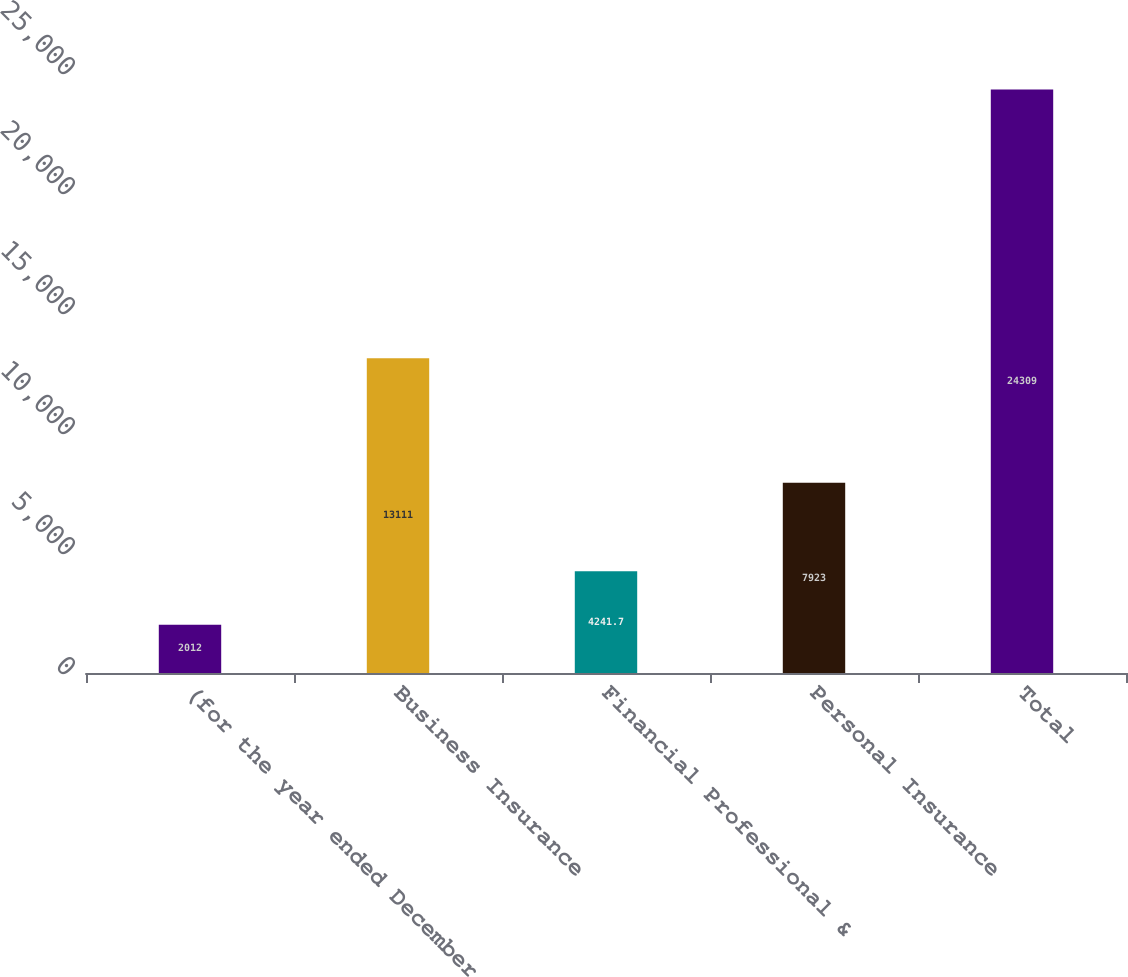<chart> <loc_0><loc_0><loc_500><loc_500><bar_chart><fcel>(for the year ended December<fcel>Business Insurance<fcel>Financial Professional &<fcel>Personal Insurance<fcel>Total<nl><fcel>2012<fcel>13111<fcel>4241.7<fcel>7923<fcel>24309<nl></chart> 